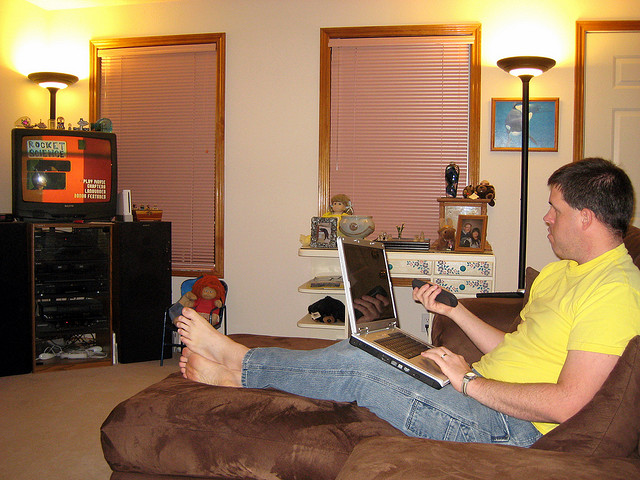Can you describe the decor style of the room? The room has a cozy and lived-in decor style, with warm lighting, a comfortable couch, and personal touches like the lamp, blinds, and items on the shelf that suggest a personal and casual living space. What does the presence of the television suggest about the room's use? The presence of the television, prominently placed, indicates that this room is likely used for relaxation and entertainment, possibly serving as a living or family room. 